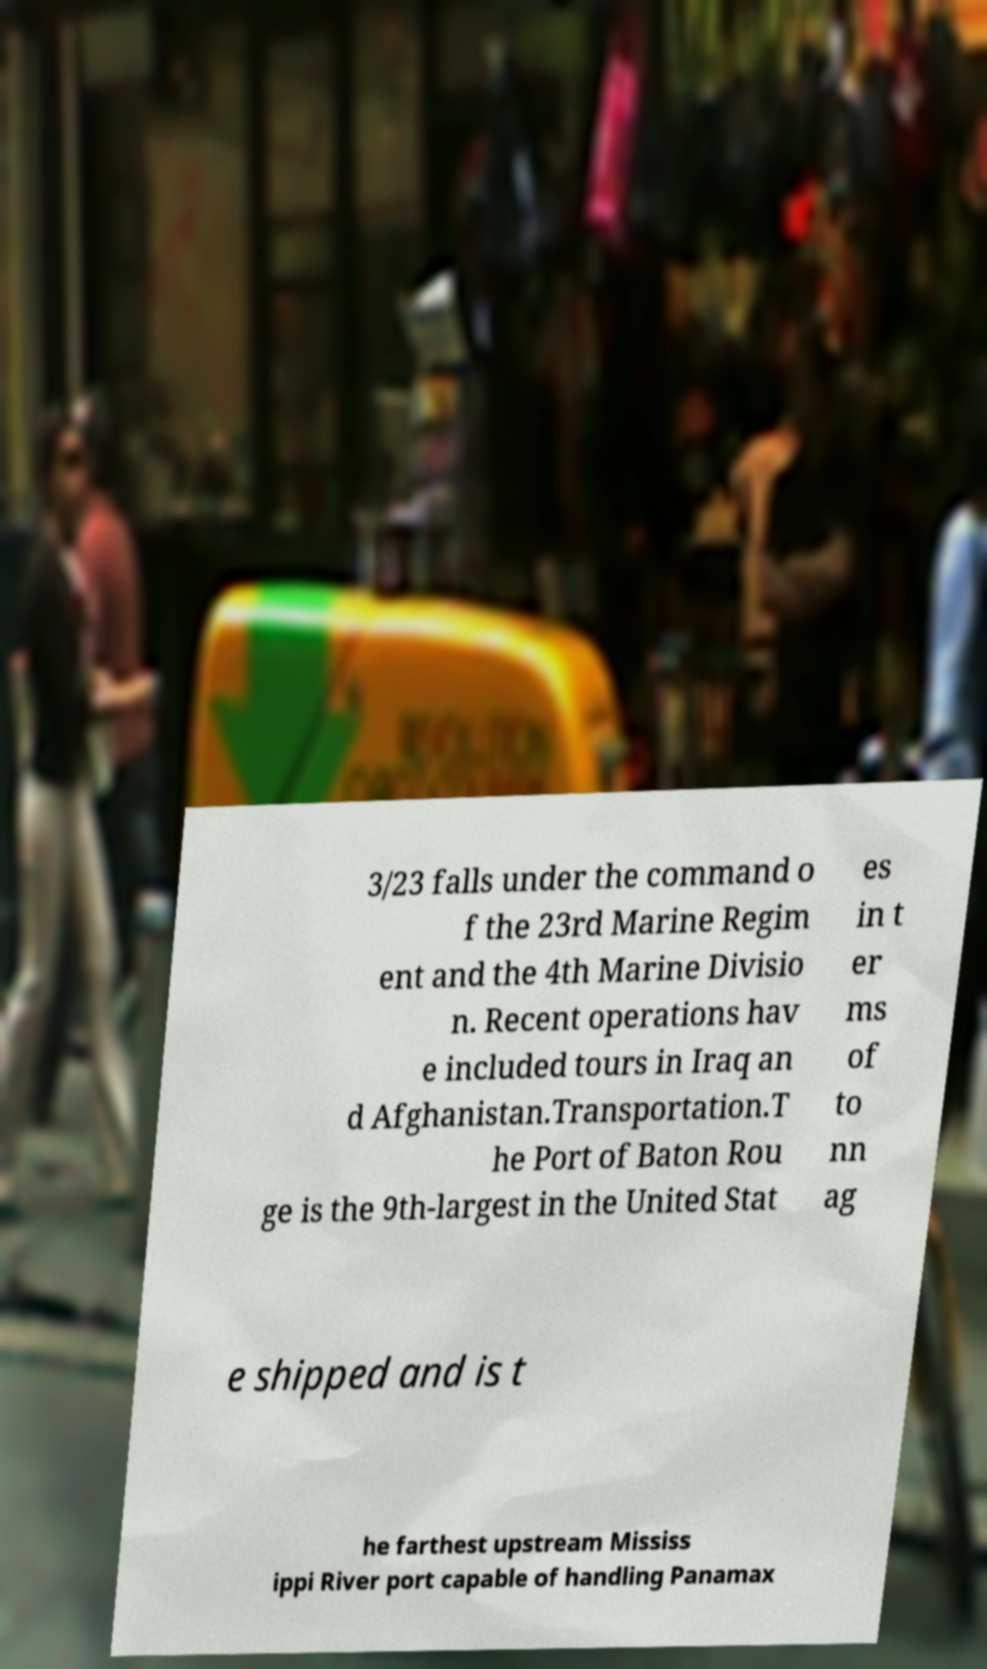For documentation purposes, I need the text within this image transcribed. Could you provide that? 3/23 falls under the command o f the 23rd Marine Regim ent and the 4th Marine Divisio n. Recent operations hav e included tours in Iraq an d Afghanistan.Transportation.T he Port of Baton Rou ge is the 9th-largest in the United Stat es in t er ms of to nn ag e shipped and is t he farthest upstream Mississ ippi River port capable of handling Panamax 